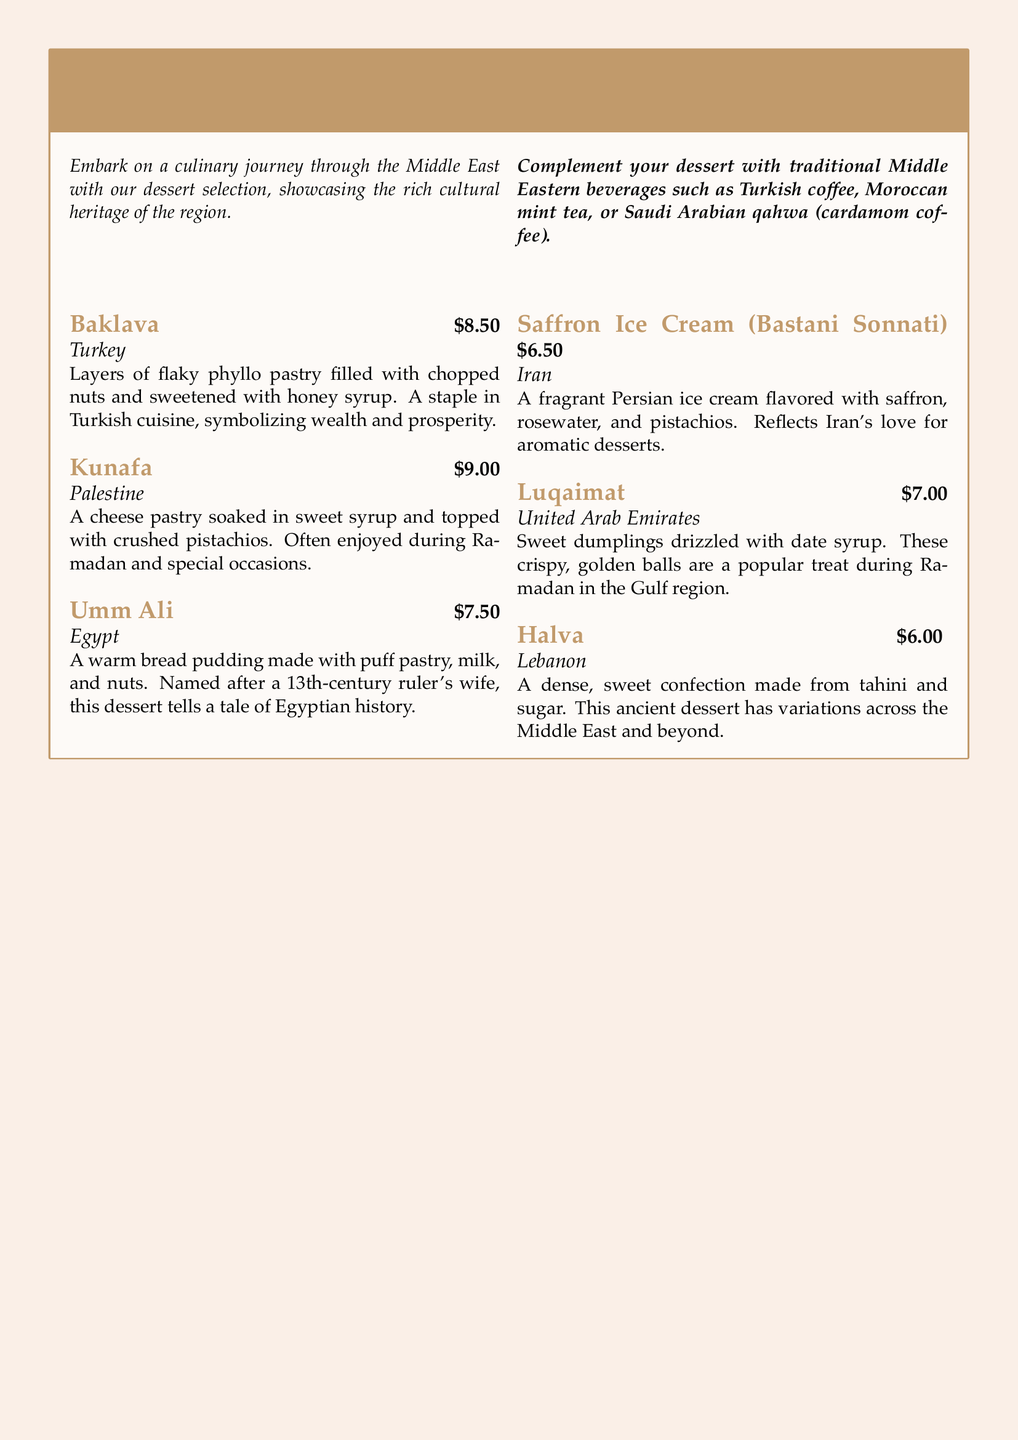What is the price of Baklava? The price of Baklava is stated in the document as $8.50.
Answer: $8.50 Which country is associated with Kunafa? The document explicitly mentions that Kunafa originates from Palestine.
Answer: Palestine What type of dessert is Umm Ali? The document describes Umm Ali as a warm bread pudding.
Answer: warm bread pudding How much does Saffron Ice Cream cost? The cost of Saffron Ice Cream (Bastani Sonnati) is specified as $6.50 in the menu.
Answer: $6.50 Which dessert is a popular treat during Ramadan in the Gulf region? The document indicates that Luqaimat is a popular treat during Ramadan in the Gulf region.
Answer: Luqaimat What sweetener is used in Halva? The document states that Halva is made from tahini and sugar, indicating sugar as the sweetener.
Answer: sugar Which dessert symbolizes wealth and prosperity? According to the document, Baklava symbolizes wealth and prosperity.
Answer: Baklava Name a traditional beverage to complement the desserts. The document mentions Turkish coffee as a traditional beverage to complement the desserts.
Answer: Turkish coffee 